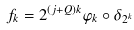Convert formula to latex. <formula><loc_0><loc_0><loc_500><loc_500>f _ { k } = 2 ^ { ( j + Q ) k } \varphi _ { k } \circ \delta _ { 2 ^ { k } }</formula> 